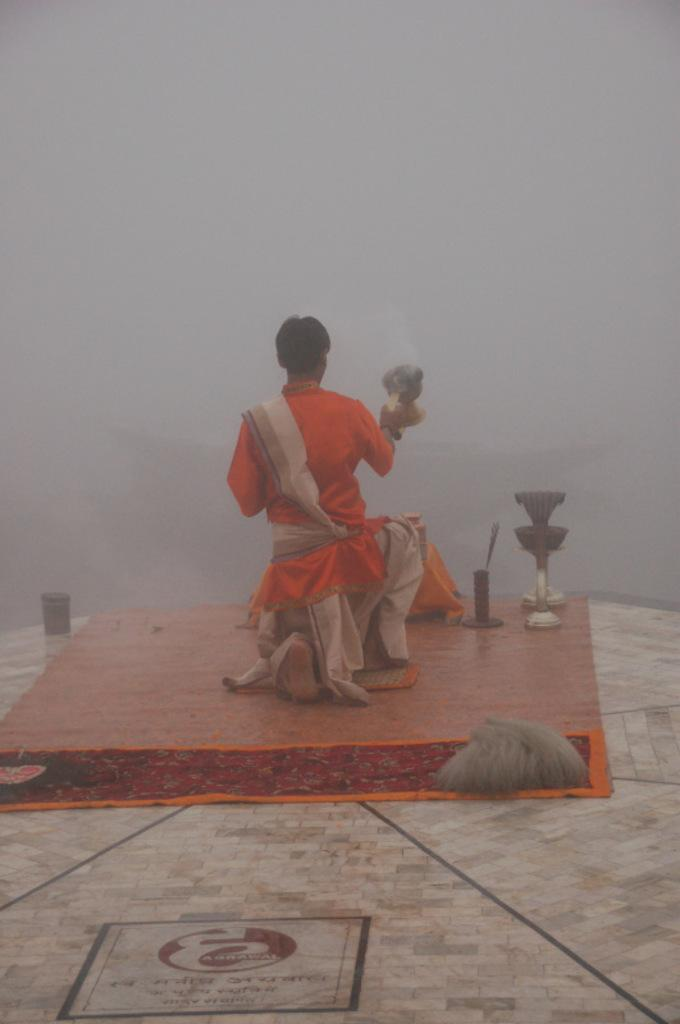What is the main subject of the image? There is a man in the image. What is the man wearing? The man is wearing an orange dress. Can you describe any other elements in the image? There are other unspecified elements in the image, but their details are not provided. Is there any text visible in the image? Yes, there is text visible in the image. What type of quill is the man holding in the image? There is no quill present in the image; the man is wearing an orange dress, but no other objects are mentioned. 